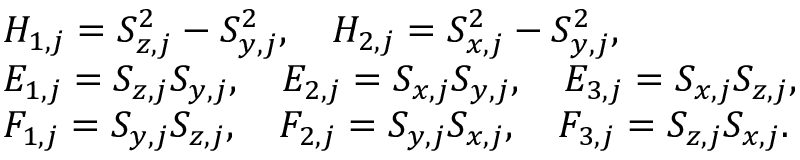<formula> <loc_0><loc_0><loc_500><loc_500>\begin{array} { r l } & { H _ { 1 , j } = S _ { z , j } ^ { 2 } - S _ { y , j } ^ { 2 } , \quad H _ { 2 , j } = S _ { x , j } ^ { 2 } - S _ { y , j } ^ { 2 } , } \\ & { E _ { 1 , j } = S _ { z , j } S _ { y , j } , \quad E _ { 2 , j } = S _ { x , j } S _ { y , j } , \quad E _ { 3 , j } = S _ { x , j } S _ { z , j } , } \\ & { F _ { 1 , j } = S _ { y , j } S _ { z , j } , \quad F _ { 2 , j } = S _ { y , j } S _ { x , j } , \quad F _ { 3 , j } = S _ { z , j } S _ { x , j } . } \end{array}</formula> 